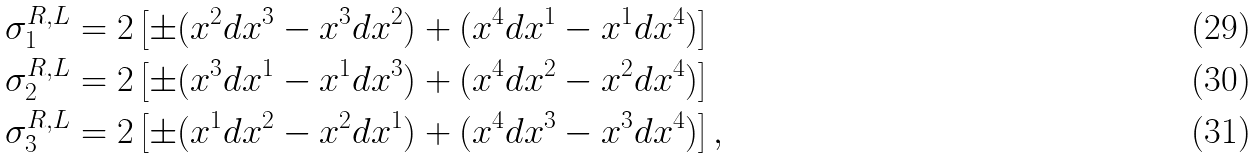Convert formula to latex. <formula><loc_0><loc_0><loc_500><loc_500>\sigma _ { 1 } ^ { R , L } & = 2 \left [ \pm ( x ^ { 2 } d x ^ { 3 } - x ^ { 3 } d x ^ { 2 } ) + ( x ^ { 4 } d x ^ { 1 } - x ^ { 1 } d x ^ { 4 } ) \right ] \\ \sigma _ { 2 } ^ { R , L } & = 2 \left [ \pm ( x ^ { 3 } d x ^ { 1 } - x ^ { 1 } d x ^ { 3 } ) + ( x ^ { 4 } d x ^ { 2 } - x ^ { 2 } d x ^ { 4 } ) \right ] \\ \sigma _ { 3 } ^ { R , L } & = 2 \left [ \pm ( x ^ { 1 } d x ^ { 2 } - x ^ { 2 } d x ^ { 1 } ) + ( x ^ { 4 } d x ^ { 3 } - x ^ { 3 } d x ^ { 4 } ) \right ] ,</formula> 